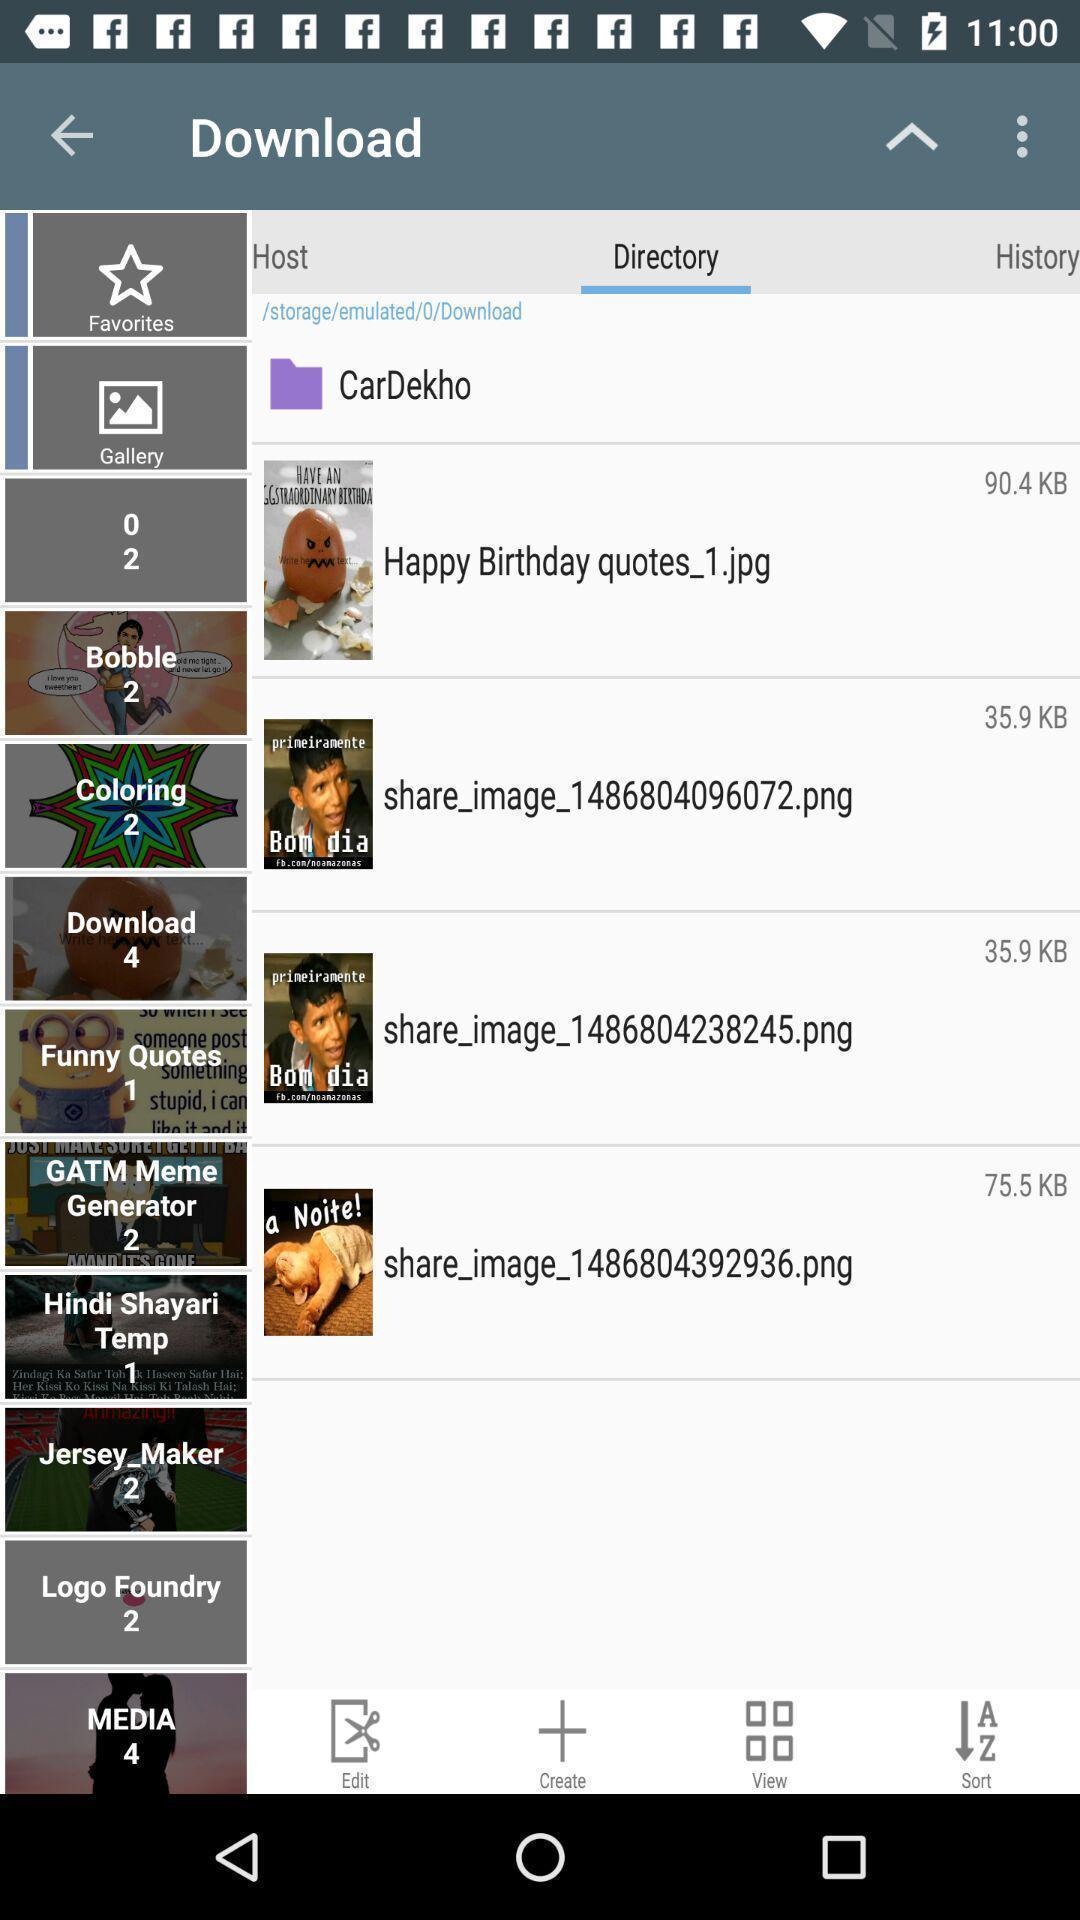Describe the content in this image. Screen shows multiple options. 